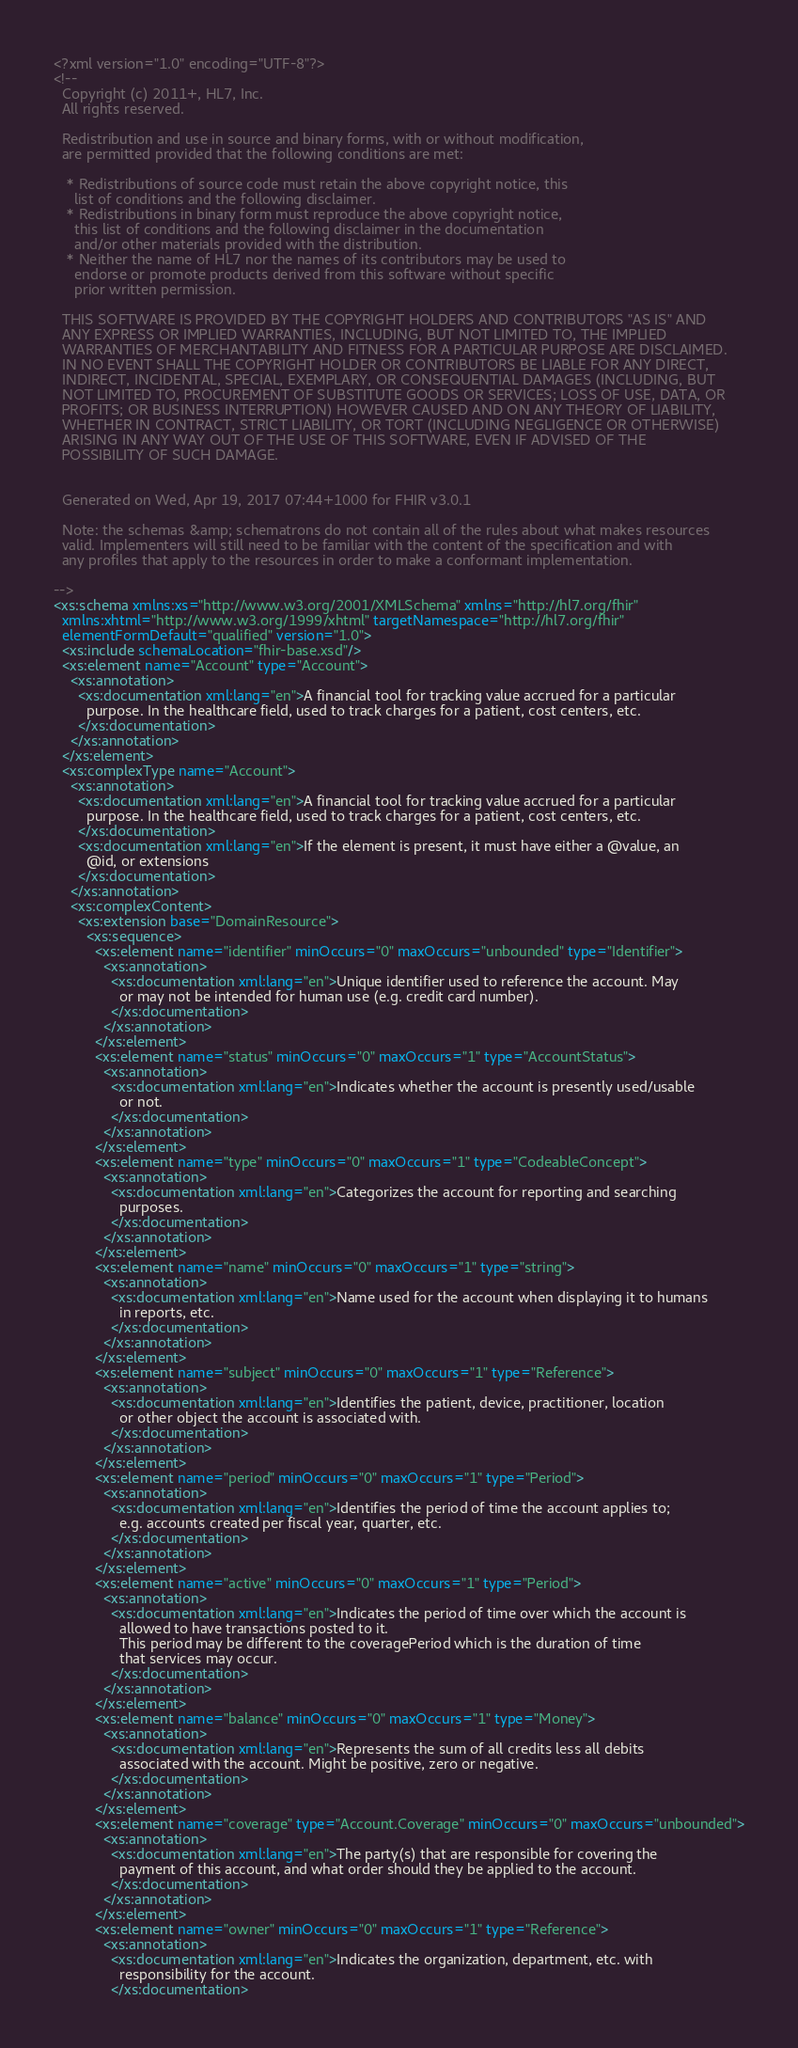Convert code to text. <code><loc_0><loc_0><loc_500><loc_500><_XML_><?xml version="1.0" encoding="UTF-8"?>
<!-- 
  Copyright (c) 2011+, HL7, Inc.
  All rights reserved.
  
  Redistribution and use in source and binary forms, with or without modification, 
  are permitted provided that the following conditions are met:
  
   * Redistributions of source code must retain the above copyright notice, this 
     list of conditions and the following disclaimer.
   * Redistributions in binary form must reproduce the above copyright notice, 
     this list of conditions and the following disclaimer in the documentation 
     and/or other materials provided with the distribution.
   * Neither the name of HL7 nor the names of its contributors may be used to 
     endorse or promote products derived from this software without specific 
     prior written permission.
  
  THIS SOFTWARE IS PROVIDED BY THE COPYRIGHT HOLDERS AND CONTRIBUTORS "AS IS" AND 
  ANY EXPRESS OR IMPLIED WARRANTIES, INCLUDING, BUT NOT LIMITED TO, THE IMPLIED 
  WARRANTIES OF MERCHANTABILITY AND FITNESS FOR A PARTICULAR PURPOSE ARE DISCLAIMED. 
  IN NO EVENT SHALL THE COPYRIGHT HOLDER OR CONTRIBUTORS BE LIABLE FOR ANY DIRECT, 
  INDIRECT, INCIDENTAL, SPECIAL, EXEMPLARY, OR CONSEQUENTIAL DAMAGES (INCLUDING, BUT 
  NOT LIMITED TO, PROCUREMENT OF SUBSTITUTE GOODS OR SERVICES; LOSS OF USE, DATA, OR 
  PROFITS; OR BUSINESS INTERRUPTION) HOWEVER CAUSED AND ON ANY THEORY OF LIABILITY, 
  WHETHER IN CONTRACT, STRICT LIABILITY, OR TORT (INCLUDING NEGLIGENCE OR OTHERWISE) 
  ARISING IN ANY WAY OUT OF THE USE OF THIS SOFTWARE, EVEN IF ADVISED OF THE 
  POSSIBILITY OF SUCH DAMAGE.
  

  Generated on Wed, Apr 19, 2017 07:44+1000 for FHIR v3.0.1 

  Note: the schemas &amp; schematrons do not contain all of the rules about what makes resources
  valid. Implementers will still need to be familiar with the content of the specification and with
  any profiles that apply to the resources in order to make a conformant implementation.

-->
<xs:schema xmlns:xs="http://www.w3.org/2001/XMLSchema" xmlns="http://hl7.org/fhir"
  xmlns:xhtml="http://www.w3.org/1999/xhtml" targetNamespace="http://hl7.org/fhir"
  elementFormDefault="qualified" version="1.0">
  <xs:include schemaLocation="fhir-base.xsd"/>
  <xs:element name="Account" type="Account">
    <xs:annotation>
      <xs:documentation xml:lang="en">A financial tool for tracking value accrued for a particular
        purpose. In the healthcare field, used to track charges for a patient, cost centers, etc.
      </xs:documentation>
    </xs:annotation>
  </xs:element>
  <xs:complexType name="Account">
    <xs:annotation>
      <xs:documentation xml:lang="en">A financial tool for tracking value accrued for a particular
        purpose. In the healthcare field, used to track charges for a patient, cost centers, etc.
      </xs:documentation>
      <xs:documentation xml:lang="en">If the element is present, it must have either a @value, an
        @id, or extensions
      </xs:documentation>
    </xs:annotation>
    <xs:complexContent>
      <xs:extension base="DomainResource">
        <xs:sequence>
          <xs:element name="identifier" minOccurs="0" maxOccurs="unbounded" type="Identifier">
            <xs:annotation>
              <xs:documentation xml:lang="en">Unique identifier used to reference the account. May
                or may not be intended for human use (e.g. credit card number).
              </xs:documentation>
            </xs:annotation>
          </xs:element>
          <xs:element name="status" minOccurs="0" maxOccurs="1" type="AccountStatus">
            <xs:annotation>
              <xs:documentation xml:lang="en">Indicates whether the account is presently used/usable
                or not.
              </xs:documentation>
            </xs:annotation>
          </xs:element>
          <xs:element name="type" minOccurs="0" maxOccurs="1" type="CodeableConcept">
            <xs:annotation>
              <xs:documentation xml:lang="en">Categorizes the account for reporting and searching
                purposes.
              </xs:documentation>
            </xs:annotation>
          </xs:element>
          <xs:element name="name" minOccurs="0" maxOccurs="1" type="string">
            <xs:annotation>
              <xs:documentation xml:lang="en">Name used for the account when displaying it to humans
                in reports, etc.
              </xs:documentation>
            </xs:annotation>
          </xs:element>
          <xs:element name="subject" minOccurs="0" maxOccurs="1" type="Reference">
            <xs:annotation>
              <xs:documentation xml:lang="en">Identifies the patient, device, practitioner, location
                or other object the account is associated with.
              </xs:documentation>
            </xs:annotation>
          </xs:element>
          <xs:element name="period" minOccurs="0" maxOccurs="1" type="Period">
            <xs:annotation>
              <xs:documentation xml:lang="en">Identifies the period of time the account applies to;
                e.g. accounts created per fiscal year, quarter, etc.
              </xs:documentation>
            </xs:annotation>
          </xs:element>
          <xs:element name="active" minOccurs="0" maxOccurs="1" type="Period">
            <xs:annotation>
              <xs:documentation xml:lang="en">Indicates the period of time over which the account is
                allowed to have transactions posted to it.
                This period may be different to the coveragePeriod which is the duration of time
                that services may occur.
              </xs:documentation>
            </xs:annotation>
          </xs:element>
          <xs:element name="balance" minOccurs="0" maxOccurs="1" type="Money">
            <xs:annotation>
              <xs:documentation xml:lang="en">Represents the sum of all credits less all debits
                associated with the account. Might be positive, zero or negative.
              </xs:documentation>
            </xs:annotation>
          </xs:element>
          <xs:element name="coverage" type="Account.Coverage" minOccurs="0" maxOccurs="unbounded">
            <xs:annotation>
              <xs:documentation xml:lang="en">The party(s) that are responsible for covering the
                payment of this account, and what order should they be applied to the account.
              </xs:documentation>
            </xs:annotation>
          </xs:element>
          <xs:element name="owner" minOccurs="0" maxOccurs="1" type="Reference">
            <xs:annotation>
              <xs:documentation xml:lang="en">Indicates the organization, department, etc. with
                responsibility for the account.
              </xs:documentation></code> 